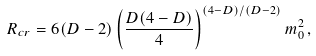Convert formula to latex. <formula><loc_0><loc_0><loc_500><loc_500>R _ { c r } = 6 ( D - 2 ) \left ( \frac { D ( 4 - D ) } { 4 } \right ) ^ { ( 4 - D ) / ( D - 2 ) } m _ { 0 } ^ { 2 } \, ,</formula> 